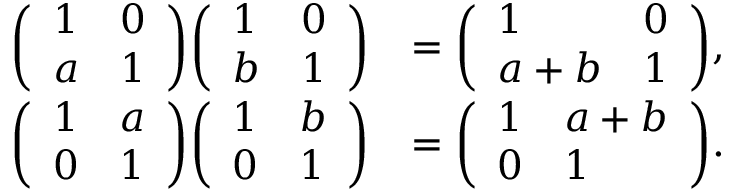Convert formula to latex. <formula><loc_0><loc_0><loc_500><loc_500>{ \begin{array} { r l } { { \left ( \begin{array} { l l } { 1 } & { 0 } \\ { a } & { 1 } \end{array} \right ) } { \left ( \begin{array} { l l } { 1 } & { 0 } \\ { b } & { 1 } \end{array} \right ) } } & { = { \left ( \begin{array} { l l } { 1 } & { 0 } \\ { a + b } & { 1 } \end{array} \right ) } , } \\ { { \left ( \begin{array} { l l } { 1 } & { a } \\ { 0 } & { 1 } \end{array} \right ) } { \left ( \begin{array} { l l } { 1 } & { b } \\ { 0 } & { 1 } \end{array} \right ) } } & { = { \left ( \begin{array} { l l } { 1 } & { a + b } \\ { 0 } & { 1 } \end{array} \right ) } . } \end{array} }</formula> 